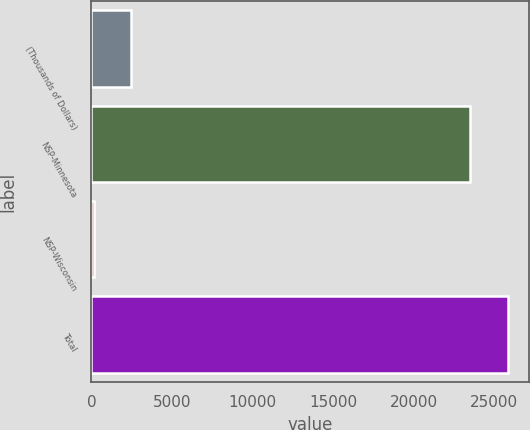Convert chart. <chart><loc_0><loc_0><loc_500><loc_500><bar_chart><fcel>(Thousands of Dollars)<fcel>NSP-Minnesota<fcel>NSP-Wisconsin<fcel>Total<nl><fcel>2481.5<fcel>23515<fcel>130<fcel>25866.5<nl></chart> 